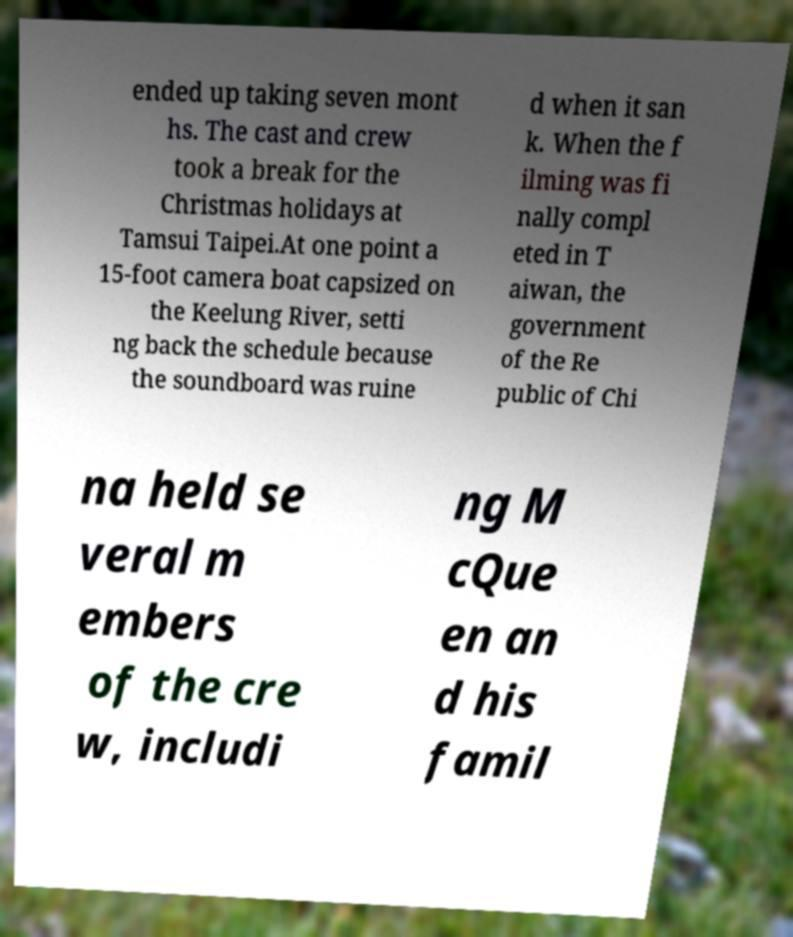Can you read and provide the text displayed in the image?This photo seems to have some interesting text. Can you extract and type it out for me? ended up taking seven mont hs. The cast and crew took a break for the Christmas holidays at Tamsui Taipei.At one point a 15-foot camera boat capsized on the Keelung River, setti ng back the schedule because the soundboard was ruine d when it san k. When the f ilming was fi nally compl eted in T aiwan, the government of the Re public of Chi na held se veral m embers of the cre w, includi ng M cQue en an d his famil 